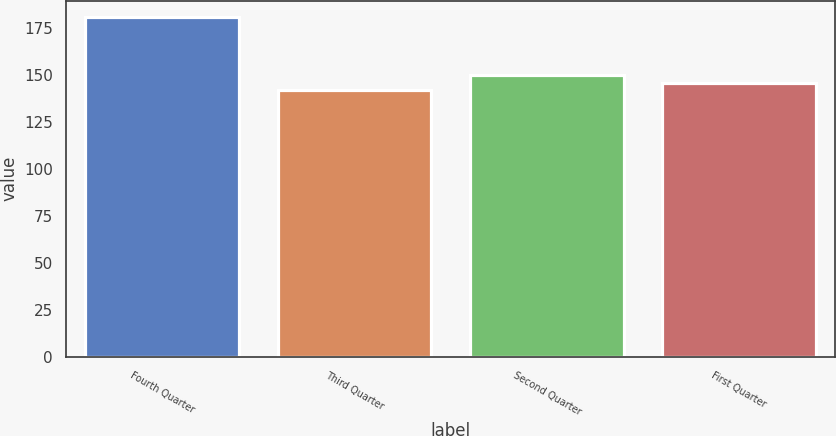<chart> <loc_0><loc_0><loc_500><loc_500><bar_chart><fcel>Fourth Quarter<fcel>Third Quarter<fcel>Second Quarter<fcel>First Quarter<nl><fcel>180.5<fcel>142<fcel>149.7<fcel>145.85<nl></chart> 